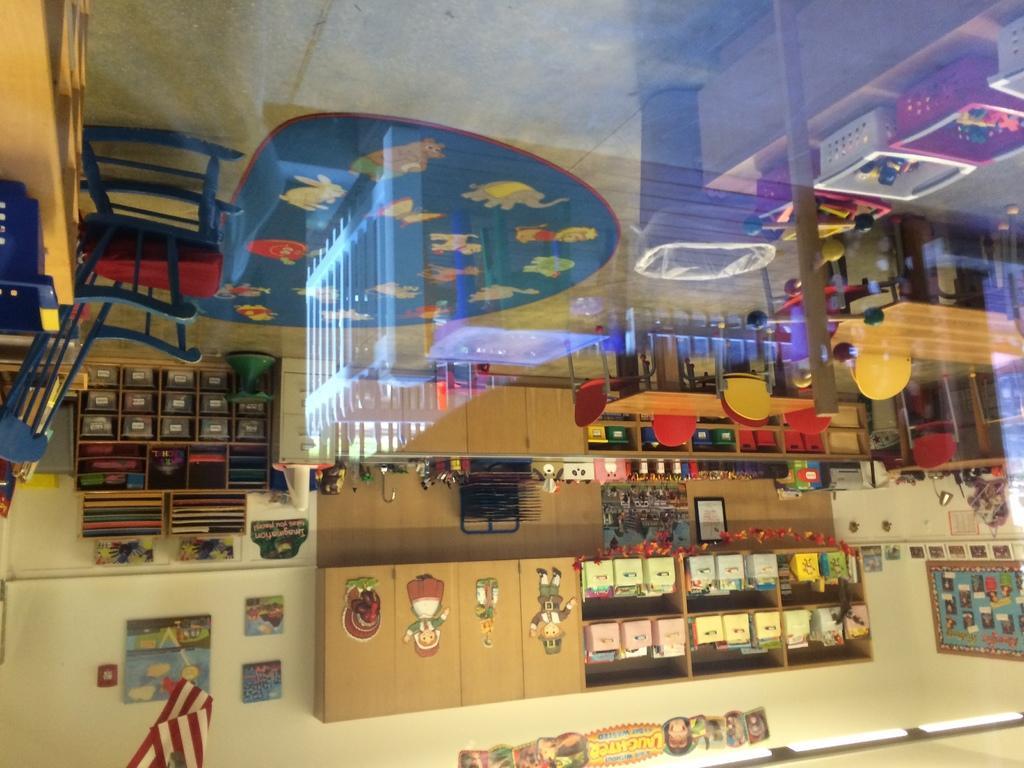Please provide a concise description of this image. In this image there are tables and chairs, behind them there are a few objects on the wooden shelves. 